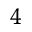<formula> <loc_0><loc_0><loc_500><loc_500>_ { 4 }</formula> 